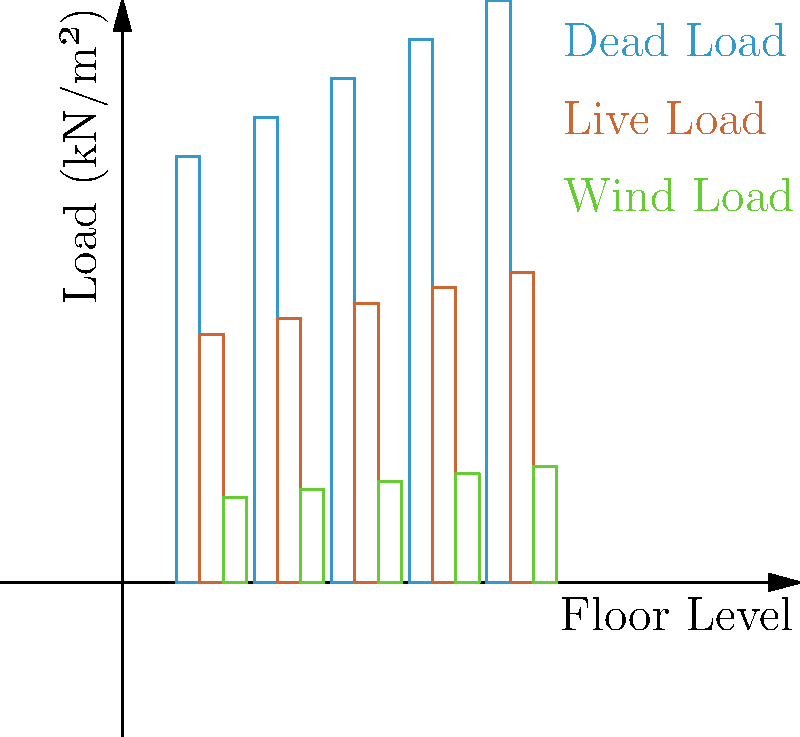In the structural load analysis for a 5-story veterinary hospital, which floor experiences the highest total load, and what is the magnitude of this load? Consider the welfare of the animals when interpreting the results. To find the floor with the highest total load and its magnitude, we need to:

1. Calculate the total load for each floor:
   - Floor 1: $5.5 + 3.2 + 1.1 = 9.8$ kN/m²
   - Floor 2: $6.0 + 3.4 + 1.2 = 10.6$ kN/m²
   - Floor 3: $6.5 + 3.6 + 1.3 = 11.4$ kN/m²
   - Floor 4: $7.0 + 3.8 + 1.4 = 12.2$ kN/m²
   - Floor 5: $7.5 + 4.0 + 1.5 = 13.0$ kN/m²

2. Compare the total loads:
   The 5th floor has the highest total load at 13.0 kN/m².

3. Interpret the results:
   The increasing load on higher floors is due to the cumulative effect of dead loads (building materials), live loads (occupants and equipment), and wind loads. This design ensures that the structure can safely support the weight of animals, staff, and medical equipment on all floors, with extra capacity on upper levels for potential future expansions or additional equipment.
Answer: 5th floor, 13.0 kN/m² 